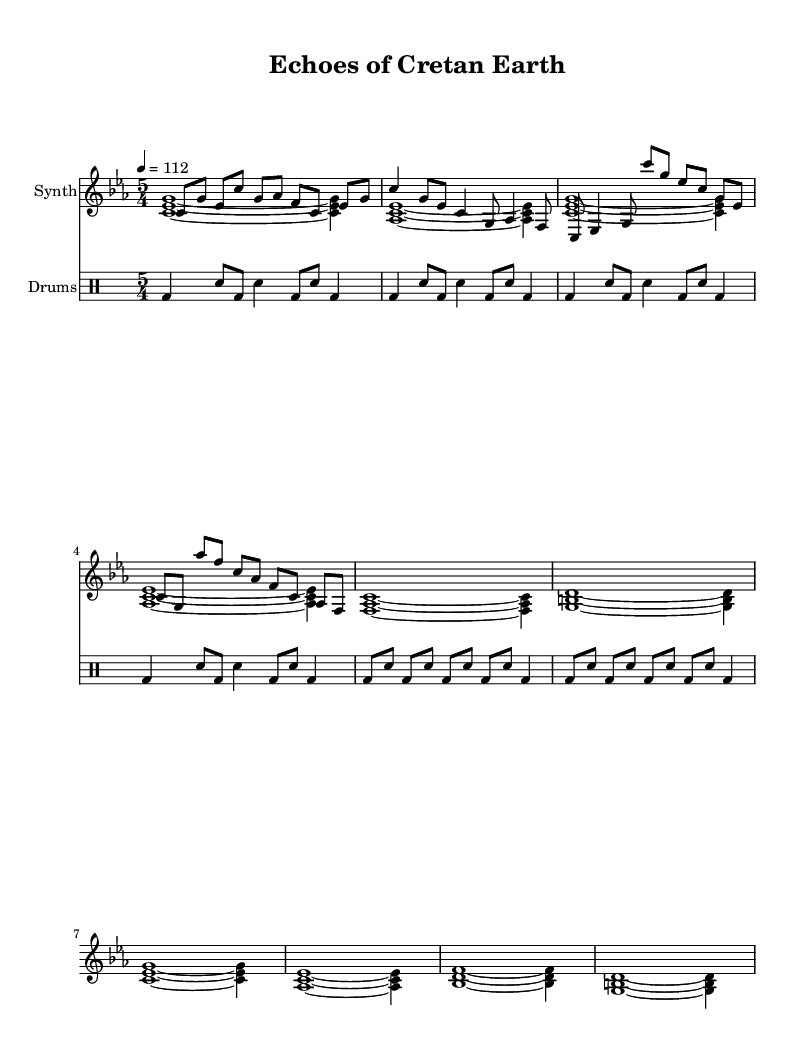What is the key signature of this music? The key signature is indicated at the beginning of the music notation. It shows C minor, which has three flats (B flat, E flat, and A flat).
Answer: C minor What is the time signature of this piece? The time signature appears at the beginning and shows a 5/4 time, indicating there are five beats per measure and that the quarter note gets one beat.
Answer: 5/4 What is the tempo marking of the piece? The tempo is notated above the staff with a metronome marking of 112, indicating that the piece should be played at a speed of 112 beats per minute.
Answer: 112 How many sections does this composition have? The composition has three distinct sections: Intro, Verse, and Chorus, which can be identified by their different musical patterns and structures.
Answer: Three What instrument is the main melody played on? The main melody is written for synthesizer, as indicated by "Synth" in the instrument name associated with the staff for the melody.
Answer: Synth Which part features field recordings in the composition? The composition incorporates field recordings, particularly in the background or atmospheric sound layers, which are characteristic of experimental electronic music, but they are not explicitly notated in the sheet music.
Answer: Not explicitly notated In which section does the harmony change? The harmony changes notably between the chorus and the verse, as can be seen in the chord sequences, where the progression of harmonies shifts from stable to more varied structures.
Answer: In the chorus 